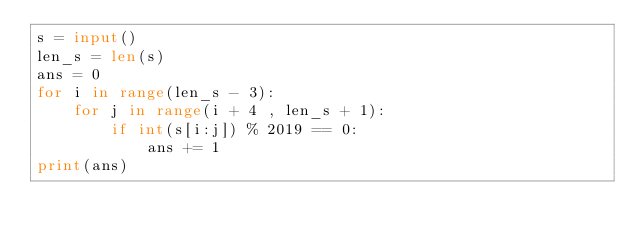Convert code to text. <code><loc_0><loc_0><loc_500><loc_500><_Python_>s = input()
len_s = len(s)
ans = 0
for i in range(len_s - 3):
    for j in range(i + 4 , len_s + 1):
        if int(s[i:j]) % 2019 == 0:
            ans += 1
print(ans)</code> 